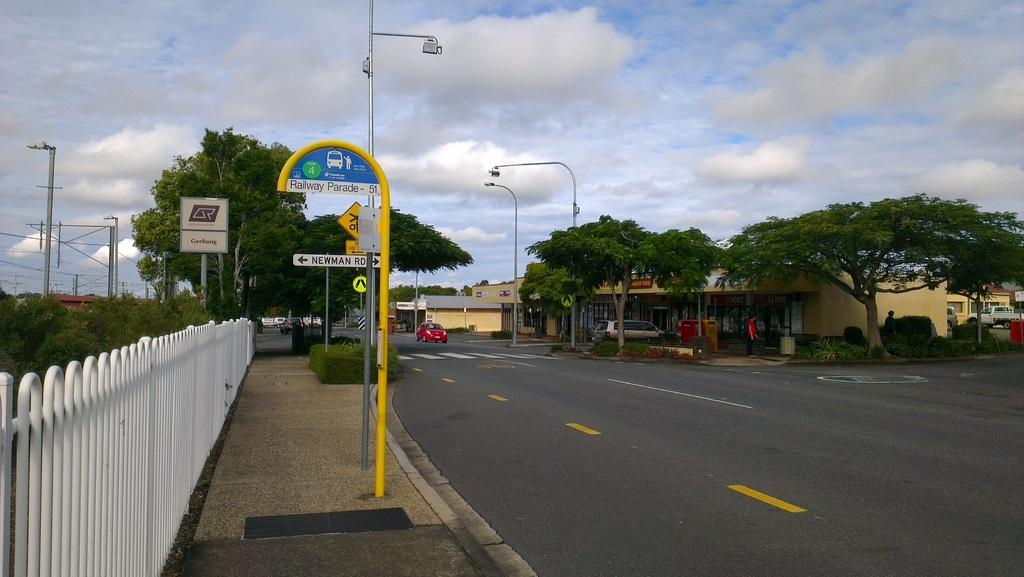<image>
Give a short and clear explanation of the subsequent image. A road with a bus stop for zone 4 on the left side. 